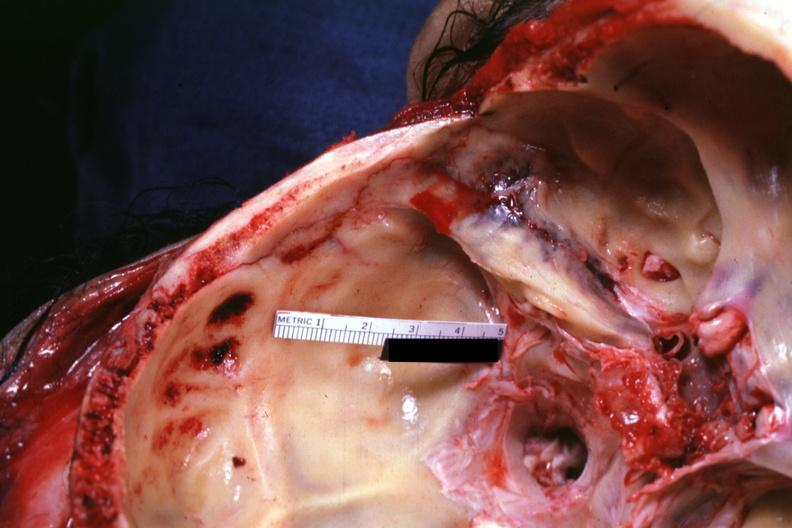does this image show close-up of linear fracture very well?
Answer the question using a single word or phrase. Yes 